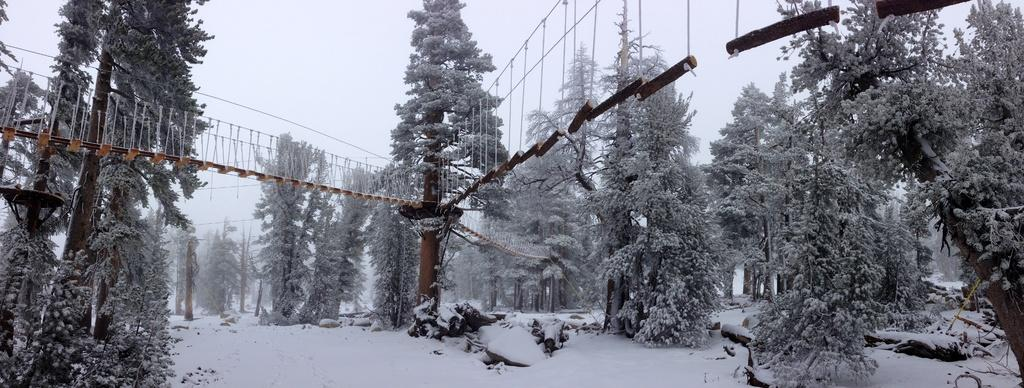What type of vegetation can be seen in the image? There are trees in the image. What is visible in the background of the image? The sky is visible in the image. How is the bridge connected to the tree in the image? There is a bridge attached to a tree in the image. What is the weather like in the image? There is snow fall on the land in the image, indicating a snowy or cold weather. What type of noise can be heard coming from the yam in the image? There is no yam present in the image, and therefore no noise can be heard from it. 